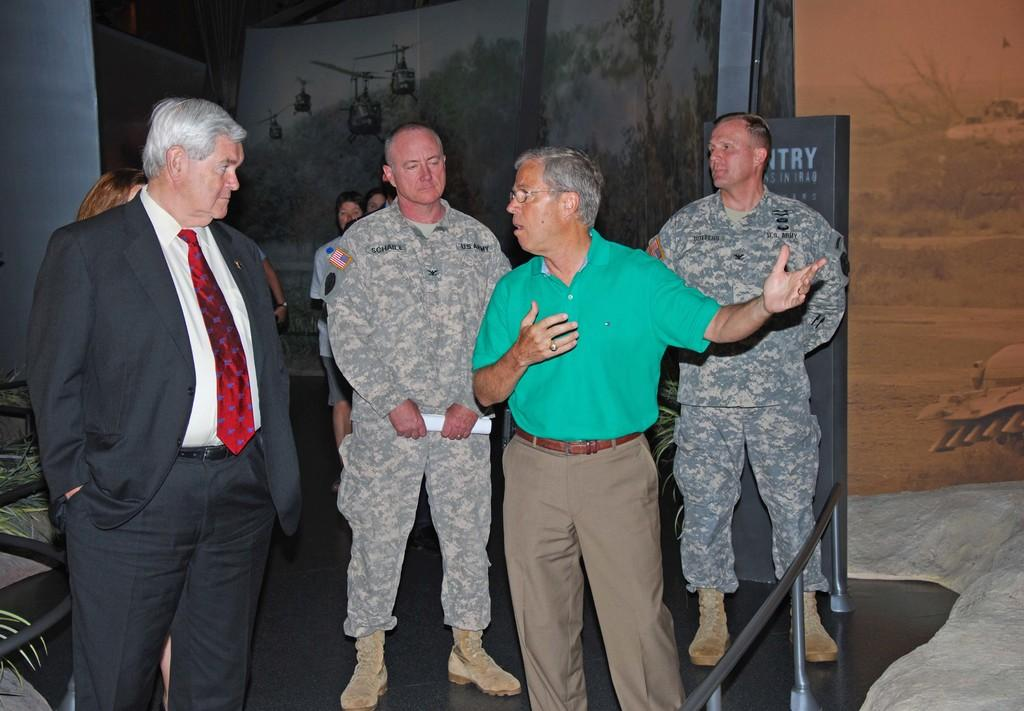What is happening in the image? There is a group of people standing in the image. What can be seen in the background of the image? There are posters in the background of the image. What is on the right side of the image? There is a barrier on the right side of the image. What type of bun is being used to hold the spoon in the image? There is no bun or spoon present in the image. How many arms are visible in the image? The number of arms visible in the image cannot be determined from the provided facts. 